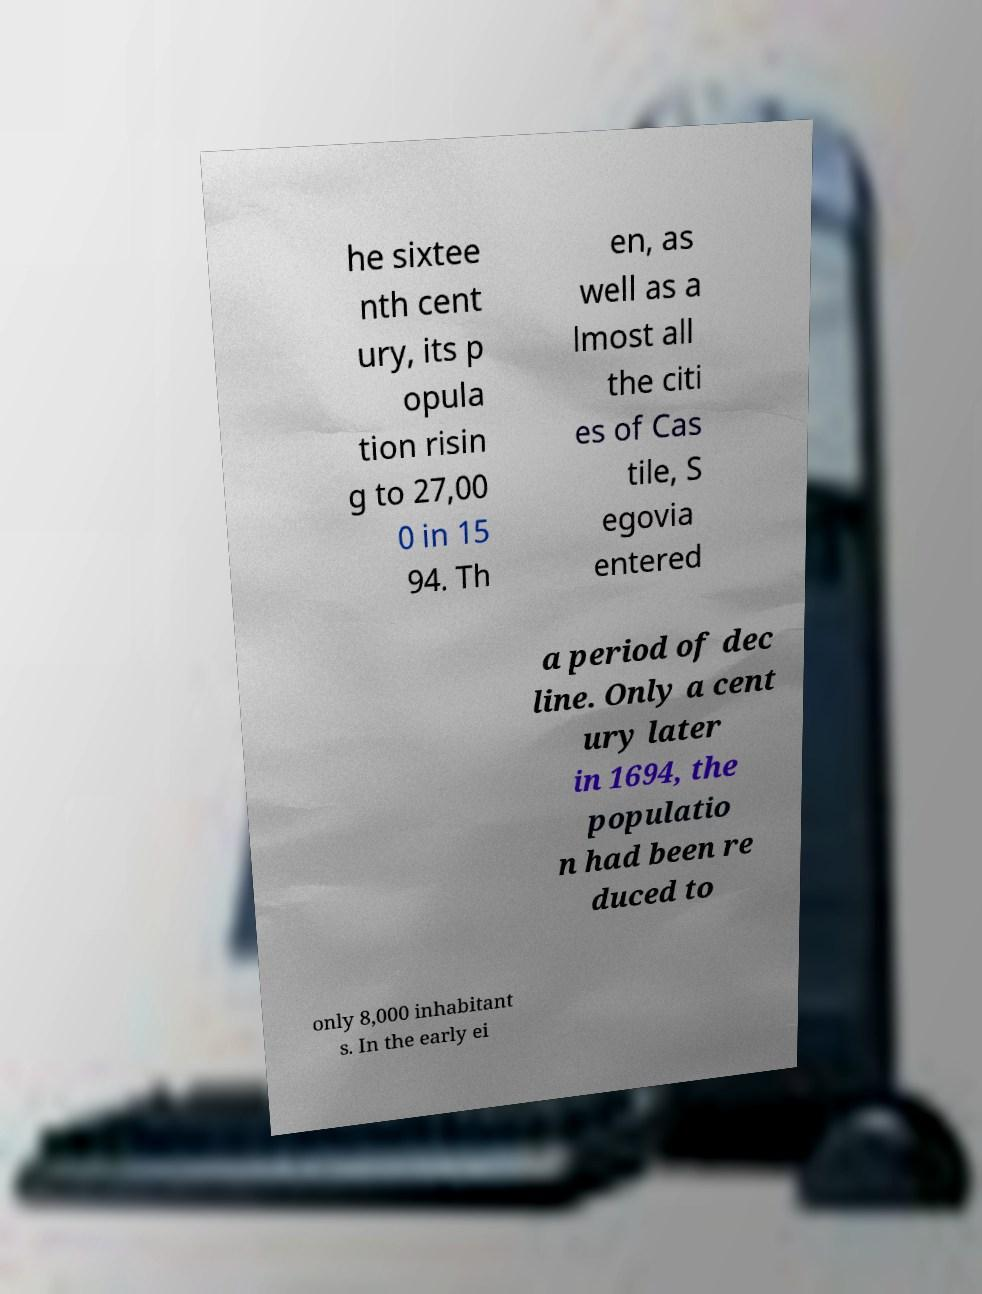Could you assist in decoding the text presented in this image and type it out clearly? he sixtee nth cent ury, its p opula tion risin g to 27,00 0 in 15 94. Th en, as well as a lmost all the citi es of Cas tile, S egovia entered a period of dec line. Only a cent ury later in 1694, the populatio n had been re duced to only 8,000 inhabitant s. In the early ei 